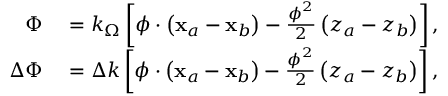Convert formula to latex. <formula><loc_0><loc_0><loc_500><loc_500>\begin{array} { r l } { \Phi } & = k _ { \Omega } \left [ \phi \cdot \left ( x _ { a } - x _ { b } \right ) - \frac { \phi ^ { 2 } } { 2 } \left ( z _ { a } - z _ { b } \right ) \right ] , } \\ { \Delta \Phi } & = \Delta k \left [ \phi \cdot \left ( x _ { a } - x _ { b } \right ) - \frac { \phi ^ { 2 } } { 2 } \left ( z _ { a } - z _ { b } \right ) \right ] , } \end{array}</formula> 